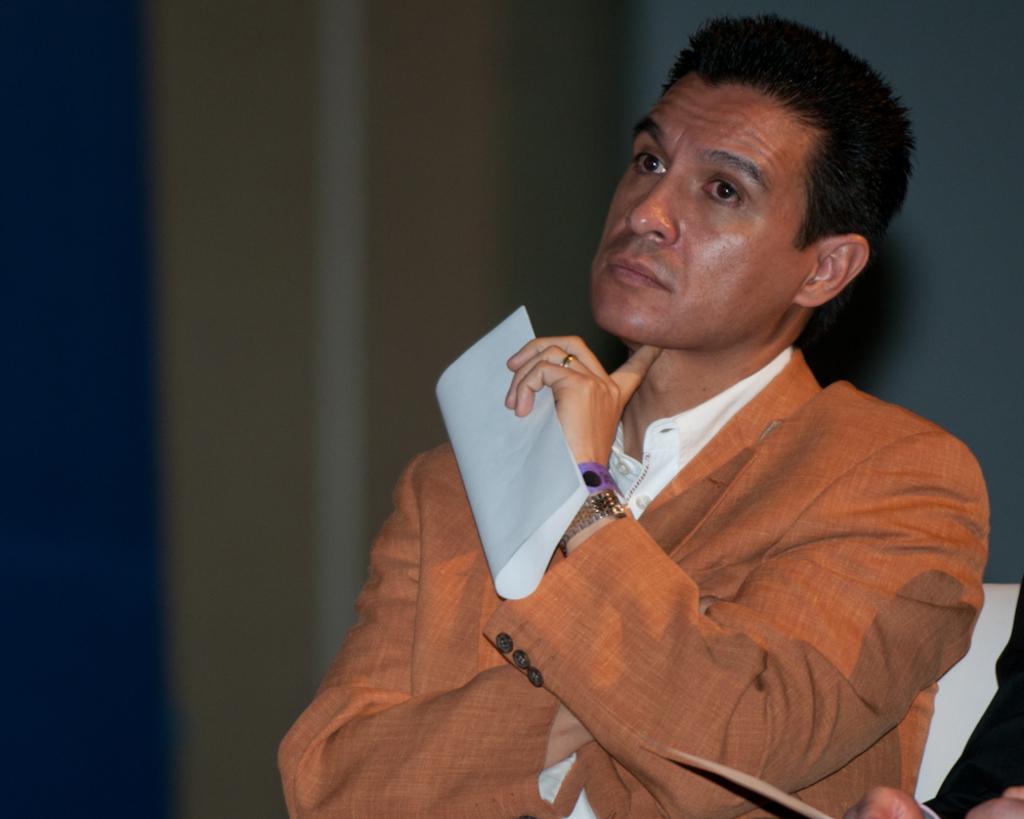How would you summarize this image in a sentence or two? In the center of the image we can see a person holding some object and he is in a different costume. At the bottom right side of the image, we can see some objects. In the background, we can see it is blurred. 